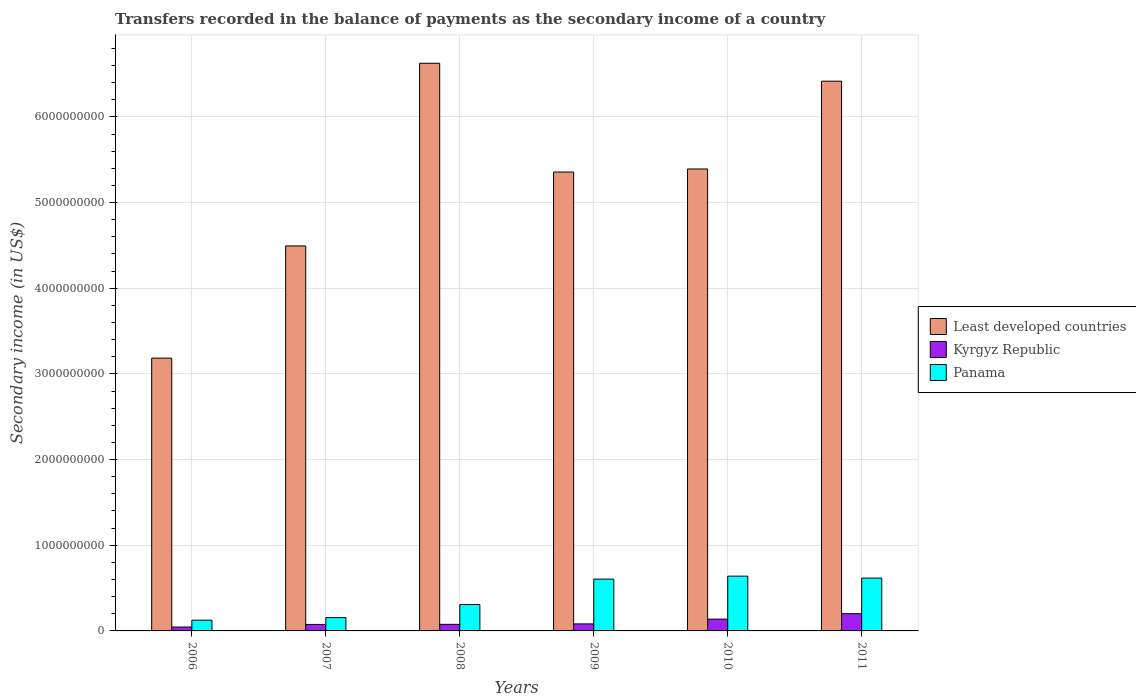How many groups of bars are there?
Offer a terse response. 6. Are the number of bars per tick equal to the number of legend labels?
Make the answer very short. Yes. How many bars are there on the 2nd tick from the right?
Your answer should be very brief. 3. What is the secondary income of in Panama in 2009?
Your answer should be compact. 6.05e+08. Across all years, what is the maximum secondary income of in Kyrgyz Republic?
Your answer should be compact. 2.01e+08. Across all years, what is the minimum secondary income of in Panama?
Your response must be concise. 1.26e+08. What is the total secondary income of in Kyrgyz Republic in the graph?
Give a very brief answer. 6.18e+08. What is the difference between the secondary income of in Panama in 2008 and that in 2010?
Provide a succinct answer. -3.31e+08. What is the difference between the secondary income of in Least developed countries in 2011 and the secondary income of in Panama in 2007?
Provide a short and direct response. 6.26e+09. What is the average secondary income of in Least developed countries per year?
Offer a terse response. 5.24e+09. In the year 2006, what is the difference between the secondary income of in Kyrgyz Republic and secondary income of in Panama?
Your answer should be compact. -8.02e+07. In how many years, is the secondary income of in Least developed countries greater than 4400000000 US$?
Give a very brief answer. 5. What is the ratio of the secondary income of in Kyrgyz Republic in 2009 to that in 2011?
Your answer should be compact. 0.41. What is the difference between the highest and the second highest secondary income of in Panama?
Make the answer very short. 2.26e+07. What is the difference between the highest and the lowest secondary income of in Panama?
Your answer should be compact. 5.14e+08. In how many years, is the secondary income of in Kyrgyz Republic greater than the average secondary income of in Kyrgyz Republic taken over all years?
Your answer should be very brief. 2. Is the sum of the secondary income of in Kyrgyz Republic in 2007 and 2011 greater than the maximum secondary income of in Panama across all years?
Offer a terse response. No. What does the 3rd bar from the left in 2006 represents?
Your answer should be very brief. Panama. What does the 2nd bar from the right in 2007 represents?
Keep it short and to the point. Kyrgyz Republic. Is it the case that in every year, the sum of the secondary income of in Least developed countries and secondary income of in Kyrgyz Republic is greater than the secondary income of in Panama?
Ensure brevity in your answer.  Yes. How many years are there in the graph?
Keep it short and to the point. 6. Are the values on the major ticks of Y-axis written in scientific E-notation?
Offer a terse response. No. Does the graph contain any zero values?
Your answer should be compact. No. How many legend labels are there?
Make the answer very short. 3. What is the title of the graph?
Provide a succinct answer. Transfers recorded in the balance of payments as the secondary income of a country. What is the label or title of the Y-axis?
Your answer should be very brief. Secondary income (in US$). What is the Secondary income (in US$) in Least developed countries in 2006?
Give a very brief answer. 3.18e+09. What is the Secondary income (in US$) in Kyrgyz Republic in 2006?
Ensure brevity in your answer.  4.53e+07. What is the Secondary income (in US$) of Panama in 2006?
Make the answer very short. 1.26e+08. What is the Secondary income (in US$) in Least developed countries in 2007?
Your answer should be compact. 4.49e+09. What is the Secondary income (in US$) of Kyrgyz Republic in 2007?
Offer a terse response. 7.56e+07. What is the Secondary income (in US$) in Panama in 2007?
Provide a short and direct response. 1.56e+08. What is the Secondary income (in US$) in Least developed countries in 2008?
Your answer should be very brief. 6.63e+09. What is the Secondary income (in US$) of Kyrgyz Republic in 2008?
Offer a very short reply. 7.67e+07. What is the Secondary income (in US$) of Panama in 2008?
Keep it short and to the point. 3.08e+08. What is the Secondary income (in US$) of Least developed countries in 2009?
Your response must be concise. 5.36e+09. What is the Secondary income (in US$) of Kyrgyz Republic in 2009?
Provide a succinct answer. 8.20e+07. What is the Secondary income (in US$) in Panama in 2009?
Keep it short and to the point. 6.05e+08. What is the Secondary income (in US$) in Least developed countries in 2010?
Make the answer very short. 5.39e+09. What is the Secondary income (in US$) in Kyrgyz Republic in 2010?
Your answer should be very brief. 1.38e+08. What is the Secondary income (in US$) of Panama in 2010?
Keep it short and to the point. 6.39e+08. What is the Secondary income (in US$) in Least developed countries in 2011?
Ensure brevity in your answer.  6.42e+09. What is the Secondary income (in US$) of Kyrgyz Republic in 2011?
Provide a short and direct response. 2.01e+08. What is the Secondary income (in US$) of Panama in 2011?
Your answer should be very brief. 6.17e+08. Across all years, what is the maximum Secondary income (in US$) in Least developed countries?
Your answer should be very brief. 6.63e+09. Across all years, what is the maximum Secondary income (in US$) in Kyrgyz Republic?
Give a very brief answer. 2.01e+08. Across all years, what is the maximum Secondary income (in US$) of Panama?
Provide a short and direct response. 6.39e+08. Across all years, what is the minimum Secondary income (in US$) of Least developed countries?
Offer a terse response. 3.18e+09. Across all years, what is the minimum Secondary income (in US$) of Kyrgyz Republic?
Provide a succinct answer. 4.53e+07. Across all years, what is the minimum Secondary income (in US$) in Panama?
Ensure brevity in your answer.  1.26e+08. What is the total Secondary income (in US$) of Least developed countries in the graph?
Ensure brevity in your answer.  3.15e+1. What is the total Secondary income (in US$) of Kyrgyz Republic in the graph?
Provide a succinct answer. 6.18e+08. What is the total Secondary income (in US$) of Panama in the graph?
Make the answer very short. 2.45e+09. What is the difference between the Secondary income (in US$) in Least developed countries in 2006 and that in 2007?
Your answer should be very brief. -1.31e+09. What is the difference between the Secondary income (in US$) of Kyrgyz Republic in 2006 and that in 2007?
Your answer should be compact. -3.03e+07. What is the difference between the Secondary income (in US$) in Panama in 2006 and that in 2007?
Keep it short and to the point. -3.05e+07. What is the difference between the Secondary income (in US$) in Least developed countries in 2006 and that in 2008?
Offer a terse response. -3.44e+09. What is the difference between the Secondary income (in US$) in Kyrgyz Republic in 2006 and that in 2008?
Provide a succinct answer. -3.14e+07. What is the difference between the Secondary income (in US$) of Panama in 2006 and that in 2008?
Offer a terse response. -1.82e+08. What is the difference between the Secondary income (in US$) in Least developed countries in 2006 and that in 2009?
Offer a terse response. -2.17e+09. What is the difference between the Secondary income (in US$) of Kyrgyz Republic in 2006 and that in 2009?
Offer a terse response. -3.68e+07. What is the difference between the Secondary income (in US$) of Panama in 2006 and that in 2009?
Your response must be concise. -4.79e+08. What is the difference between the Secondary income (in US$) in Least developed countries in 2006 and that in 2010?
Offer a very short reply. -2.21e+09. What is the difference between the Secondary income (in US$) in Kyrgyz Republic in 2006 and that in 2010?
Provide a short and direct response. -9.25e+07. What is the difference between the Secondary income (in US$) in Panama in 2006 and that in 2010?
Provide a succinct answer. -5.14e+08. What is the difference between the Secondary income (in US$) of Least developed countries in 2006 and that in 2011?
Your response must be concise. -3.23e+09. What is the difference between the Secondary income (in US$) of Kyrgyz Republic in 2006 and that in 2011?
Make the answer very short. -1.56e+08. What is the difference between the Secondary income (in US$) in Panama in 2006 and that in 2011?
Ensure brevity in your answer.  -4.91e+08. What is the difference between the Secondary income (in US$) of Least developed countries in 2007 and that in 2008?
Keep it short and to the point. -2.13e+09. What is the difference between the Secondary income (in US$) of Kyrgyz Republic in 2007 and that in 2008?
Ensure brevity in your answer.  -1.10e+06. What is the difference between the Secondary income (in US$) of Panama in 2007 and that in 2008?
Give a very brief answer. -1.52e+08. What is the difference between the Secondary income (in US$) in Least developed countries in 2007 and that in 2009?
Keep it short and to the point. -8.62e+08. What is the difference between the Secondary income (in US$) in Kyrgyz Republic in 2007 and that in 2009?
Provide a succinct answer. -6.46e+06. What is the difference between the Secondary income (in US$) of Panama in 2007 and that in 2009?
Provide a short and direct response. -4.49e+08. What is the difference between the Secondary income (in US$) of Least developed countries in 2007 and that in 2010?
Your answer should be compact. -8.98e+08. What is the difference between the Secondary income (in US$) in Kyrgyz Republic in 2007 and that in 2010?
Offer a terse response. -6.22e+07. What is the difference between the Secondary income (in US$) of Panama in 2007 and that in 2010?
Provide a succinct answer. -4.83e+08. What is the difference between the Secondary income (in US$) in Least developed countries in 2007 and that in 2011?
Your answer should be very brief. -1.92e+09. What is the difference between the Secondary income (in US$) in Kyrgyz Republic in 2007 and that in 2011?
Offer a very short reply. -1.26e+08. What is the difference between the Secondary income (in US$) in Panama in 2007 and that in 2011?
Keep it short and to the point. -4.61e+08. What is the difference between the Secondary income (in US$) of Least developed countries in 2008 and that in 2009?
Offer a terse response. 1.27e+09. What is the difference between the Secondary income (in US$) of Kyrgyz Republic in 2008 and that in 2009?
Offer a terse response. -5.35e+06. What is the difference between the Secondary income (in US$) of Panama in 2008 and that in 2009?
Provide a short and direct response. -2.97e+08. What is the difference between the Secondary income (in US$) of Least developed countries in 2008 and that in 2010?
Provide a succinct answer. 1.23e+09. What is the difference between the Secondary income (in US$) in Kyrgyz Republic in 2008 and that in 2010?
Offer a terse response. -6.11e+07. What is the difference between the Secondary income (in US$) of Panama in 2008 and that in 2010?
Provide a succinct answer. -3.31e+08. What is the difference between the Secondary income (in US$) of Least developed countries in 2008 and that in 2011?
Your response must be concise. 2.09e+08. What is the difference between the Secondary income (in US$) in Kyrgyz Republic in 2008 and that in 2011?
Provide a succinct answer. -1.24e+08. What is the difference between the Secondary income (in US$) in Panama in 2008 and that in 2011?
Provide a succinct answer. -3.09e+08. What is the difference between the Secondary income (in US$) in Least developed countries in 2009 and that in 2010?
Ensure brevity in your answer.  -3.60e+07. What is the difference between the Secondary income (in US$) of Kyrgyz Republic in 2009 and that in 2010?
Your answer should be compact. -5.58e+07. What is the difference between the Secondary income (in US$) in Panama in 2009 and that in 2010?
Keep it short and to the point. -3.46e+07. What is the difference between the Secondary income (in US$) in Least developed countries in 2009 and that in 2011?
Keep it short and to the point. -1.06e+09. What is the difference between the Secondary income (in US$) of Kyrgyz Republic in 2009 and that in 2011?
Your answer should be compact. -1.19e+08. What is the difference between the Secondary income (in US$) in Panama in 2009 and that in 2011?
Keep it short and to the point. -1.20e+07. What is the difference between the Secondary income (in US$) in Least developed countries in 2010 and that in 2011?
Make the answer very short. -1.02e+09. What is the difference between the Secondary income (in US$) of Kyrgyz Republic in 2010 and that in 2011?
Your answer should be compact. -6.33e+07. What is the difference between the Secondary income (in US$) of Panama in 2010 and that in 2011?
Offer a terse response. 2.26e+07. What is the difference between the Secondary income (in US$) in Least developed countries in 2006 and the Secondary income (in US$) in Kyrgyz Republic in 2007?
Your answer should be very brief. 3.11e+09. What is the difference between the Secondary income (in US$) in Least developed countries in 2006 and the Secondary income (in US$) in Panama in 2007?
Provide a short and direct response. 3.03e+09. What is the difference between the Secondary income (in US$) in Kyrgyz Republic in 2006 and the Secondary income (in US$) in Panama in 2007?
Give a very brief answer. -1.11e+08. What is the difference between the Secondary income (in US$) in Least developed countries in 2006 and the Secondary income (in US$) in Kyrgyz Republic in 2008?
Provide a short and direct response. 3.11e+09. What is the difference between the Secondary income (in US$) of Least developed countries in 2006 and the Secondary income (in US$) of Panama in 2008?
Give a very brief answer. 2.88e+09. What is the difference between the Secondary income (in US$) of Kyrgyz Republic in 2006 and the Secondary income (in US$) of Panama in 2008?
Offer a terse response. -2.63e+08. What is the difference between the Secondary income (in US$) of Least developed countries in 2006 and the Secondary income (in US$) of Kyrgyz Republic in 2009?
Make the answer very short. 3.10e+09. What is the difference between the Secondary income (in US$) in Least developed countries in 2006 and the Secondary income (in US$) in Panama in 2009?
Ensure brevity in your answer.  2.58e+09. What is the difference between the Secondary income (in US$) of Kyrgyz Republic in 2006 and the Secondary income (in US$) of Panama in 2009?
Make the answer very short. -5.59e+08. What is the difference between the Secondary income (in US$) of Least developed countries in 2006 and the Secondary income (in US$) of Kyrgyz Republic in 2010?
Your answer should be compact. 3.05e+09. What is the difference between the Secondary income (in US$) of Least developed countries in 2006 and the Secondary income (in US$) of Panama in 2010?
Your response must be concise. 2.55e+09. What is the difference between the Secondary income (in US$) in Kyrgyz Republic in 2006 and the Secondary income (in US$) in Panama in 2010?
Your response must be concise. -5.94e+08. What is the difference between the Secondary income (in US$) of Least developed countries in 2006 and the Secondary income (in US$) of Kyrgyz Republic in 2011?
Your response must be concise. 2.98e+09. What is the difference between the Secondary income (in US$) in Least developed countries in 2006 and the Secondary income (in US$) in Panama in 2011?
Your answer should be compact. 2.57e+09. What is the difference between the Secondary income (in US$) in Kyrgyz Republic in 2006 and the Secondary income (in US$) in Panama in 2011?
Give a very brief answer. -5.71e+08. What is the difference between the Secondary income (in US$) in Least developed countries in 2007 and the Secondary income (in US$) in Kyrgyz Republic in 2008?
Keep it short and to the point. 4.42e+09. What is the difference between the Secondary income (in US$) in Least developed countries in 2007 and the Secondary income (in US$) in Panama in 2008?
Keep it short and to the point. 4.19e+09. What is the difference between the Secondary income (in US$) of Kyrgyz Republic in 2007 and the Secondary income (in US$) of Panama in 2008?
Your answer should be very brief. -2.32e+08. What is the difference between the Secondary income (in US$) in Least developed countries in 2007 and the Secondary income (in US$) in Kyrgyz Republic in 2009?
Provide a short and direct response. 4.41e+09. What is the difference between the Secondary income (in US$) in Least developed countries in 2007 and the Secondary income (in US$) in Panama in 2009?
Your response must be concise. 3.89e+09. What is the difference between the Secondary income (in US$) of Kyrgyz Republic in 2007 and the Secondary income (in US$) of Panama in 2009?
Give a very brief answer. -5.29e+08. What is the difference between the Secondary income (in US$) of Least developed countries in 2007 and the Secondary income (in US$) of Kyrgyz Republic in 2010?
Your answer should be compact. 4.36e+09. What is the difference between the Secondary income (in US$) in Least developed countries in 2007 and the Secondary income (in US$) in Panama in 2010?
Your response must be concise. 3.85e+09. What is the difference between the Secondary income (in US$) in Kyrgyz Republic in 2007 and the Secondary income (in US$) in Panama in 2010?
Your answer should be very brief. -5.64e+08. What is the difference between the Secondary income (in US$) of Least developed countries in 2007 and the Secondary income (in US$) of Kyrgyz Republic in 2011?
Give a very brief answer. 4.29e+09. What is the difference between the Secondary income (in US$) of Least developed countries in 2007 and the Secondary income (in US$) of Panama in 2011?
Ensure brevity in your answer.  3.88e+09. What is the difference between the Secondary income (in US$) in Kyrgyz Republic in 2007 and the Secondary income (in US$) in Panama in 2011?
Your answer should be compact. -5.41e+08. What is the difference between the Secondary income (in US$) in Least developed countries in 2008 and the Secondary income (in US$) in Kyrgyz Republic in 2009?
Your answer should be very brief. 6.54e+09. What is the difference between the Secondary income (in US$) of Least developed countries in 2008 and the Secondary income (in US$) of Panama in 2009?
Your response must be concise. 6.02e+09. What is the difference between the Secondary income (in US$) in Kyrgyz Republic in 2008 and the Secondary income (in US$) in Panama in 2009?
Ensure brevity in your answer.  -5.28e+08. What is the difference between the Secondary income (in US$) of Least developed countries in 2008 and the Secondary income (in US$) of Kyrgyz Republic in 2010?
Your answer should be very brief. 6.49e+09. What is the difference between the Secondary income (in US$) in Least developed countries in 2008 and the Secondary income (in US$) in Panama in 2010?
Your response must be concise. 5.99e+09. What is the difference between the Secondary income (in US$) of Kyrgyz Republic in 2008 and the Secondary income (in US$) of Panama in 2010?
Keep it short and to the point. -5.63e+08. What is the difference between the Secondary income (in US$) in Least developed countries in 2008 and the Secondary income (in US$) in Kyrgyz Republic in 2011?
Offer a terse response. 6.42e+09. What is the difference between the Secondary income (in US$) of Least developed countries in 2008 and the Secondary income (in US$) of Panama in 2011?
Keep it short and to the point. 6.01e+09. What is the difference between the Secondary income (in US$) in Kyrgyz Republic in 2008 and the Secondary income (in US$) in Panama in 2011?
Your answer should be very brief. -5.40e+08. What is the difference between the Secondary income (in US$) in Least developed countries in 2009 and the Secondary income (in US$) in Kyrgyz Republic in 2010?
Make the answer very short. 5.22e+09. What is the difference between the Secondary income (in US$) of Least developed countries in 2009 and the Secondary income (in US$) of Panama in 2010?
Provide a short and direct response. 4.72e+09. What is the difference between the Secondary income (in US$) of Kyrgyz Republic in 2009 and the Secondary income (in US$) of Panama in 2010?
Keep it short and to the point. -5.57e+08. What is the difference between the Secondary income (in US$) of Least developed countries in 2009 and the Secondary income (in US$) of Kyrgyz Republic in 2011?
Offer a terse response. 5.16e+09. What is the difference between the Secondary income (in US$) in Least developed countries in 2009 and the Secondary income (in US$) in Panama in 2011?
Ensure brevity in your answer.  4.74e+09. What is the difference between the Secondary income (in US$) of Kyrgyz Republic in 2009 and the Secondary income (in US$) of Panama in 2011?
Keep it short and to the point. -5.35e+08. What is the difference between the Secondary income (in US$) of Least developed countries in 2010 and the Secondary income (in US$) of Kyrgyz Republic in 2011?
Provide a succinct answer. 5.19e+09. What is the difference between the Secondary income (in US$) of Least developed countries in 2010 and the Secondary income (in US$) of Panama in 2011?
Offer a terse response. 4.78e+09. What is the difference between the Secondary income (in US$) in Kyrgyz Republic in 2010 and the Secondary income (in US$) in Panama in 2011?
Keep it short and to the point. -4.79e+08. What is the average Secondary income (in US$) of Least developed countries per year?
Provide a short and direct response. 5.24e+09. What is the average Secondary income (in US$) in Kyrgyz Republic per year?
Give a very brief answer. 1.03e+08. What is the average Secondary income (in US$) in Panama per year?
Provide a succinct answer. 4.08e+08. In the year 2006, what is the difference between the Secondary income (in US$) of Least developed countries and Secondary income (in US$) of Kyrgyz Republic?
Your answer should be very brief. 3.14e+09. In the year 2006, what is the difference between the Secondary income (in US$) in Least developed countries and Secondary income (in US$) in Panama?
Provide a succinct answer. 3.06e+09. In the year 2006, what is the difference between the Secondary income (in US$) in Kyrgyz Republic and Secondary income (in US$) in Panama?
Make the answer very short. -8.02e+07. In the year 2007, what is the difference between the Secondary income (in US$) of Least developed countries and Secondary income (in US$) of Kyrgyz Republic?
Your answer should be very brief. 4.42e+09. In the year 2007, what is the difference between the Secondary income (in US$) in Least developed countries and Secondary income (in US$) in Panama?
Provide a short and direct response. 4.34e+09. In the year 2007, what is the difference between the Secondary income (in US$) in Kyrgyz Republic and Secondary income (in US$) in Panama?
Ensure brevity in your answer.  -8.04e+07. In the year 2008, what is the difference between the Secondary income (in US$) of Least developed countries and Secondary income (in US$) of Kyrgyz Republic?
Provide a succinct answer. 6.55e+09. In the year 2008, what is the difference between the Secondary income (in US$) of Least developed countries and Secondary income (in US$) of Panama?
Provide a short and direct response. 6.32e+09. In the year 2008, what is the difference between the Secondary income (in US$) of Kyrgyz Republic and Secondary income (in US$) of Panama?
Provide a succinct answer. -2.31e+08. In the year 2009, what is the difference between the Secondary income (in US$) in Least developed countries and Secondary income (in US$) in Kyrgyz Republic?
Keep it short and to the point. 5.27e+09. In the year 2009, what is the difference between the Secondary income (in US$) of Least developed countries and Secondary income (in US$) of Panama?
Make the answer very short. 4.75e+09. In the year 2009, what is the difference between the Secondary income (in US$) in Kyrgyz Republic and Secondary income (in US$) in Panama?
Ensure brevity in your answer.  -5.23e+08. In the year 2010, what is the difference between the Secondary income (in US$) in Least developed countries and Secondary income (in US$) in Kyrgyz Republic?
Provide a short and direct response. 5.25e+09. In the year 2010, what is the difference between the Secondary income (in US$) of Least developed countries and Secondary income (in US$) of Panama?
Offer a very short reply. 4.75e+09. In the year 2010, what is the difference between the Secondary income (in US$) of Kyrgyz Republic and Secondary income (in US$) of Panama?
Keep it short and to the point. -5.01e+08. In the year 2011, what is the difference between the Secondary income (in US$) of Least developed countries and Secondary income (in US$) of Kyrgyz Republic?
Make the answer very short. 6.22e+09. In the year 2011, what is the difference between the Secondary income (in US$) in Least developed countries and Secondary income (in US$) in Panama?
Provide a short and direct response. 5.80e+09. In the year 2011, what is the difference between the Secondary income (in US$) in Kyrgyz Republic and Secondary income (in US$) in Panama?
Provide a short and direct response. -4.15e+08. What is the ratio of the Secondary income (in US$) of Least developed countries in 2006 to that in 2007?
Make the answer very short. 0.71. What is the ratio of the Secondary income (in US$) of Kyrgyz Republic in 2006 to that in 2007?
Ensure brevity in your answer.  0.6. What is the ratio of the Secondary income (in US$) of Panama in 2006 to that in 2007?
Provide a succinct answer. 0.8. What is the ratio of the Secondary income (in US$) in Least developed countries in 2006 to that in 2008?
Your response must be concise. 0.48. What is the ratio of the Secondary income (in US$) in Kyrgyz Republic in 2006 to that in 2008?
Make the answer very short. 0.59. What is the ratio of the Secondary income (in US$) in Panama in 2006 to that in 2008?
Offer a very short reply. 0.41. What is the ratio of the Secondary income (in US$) of Least developed countries in 2006 to that in 2009?
Provide a short and direct response. 0.59. What is the ratio of the Secondary income (in US$) in Kyrgyz Republic in 2006 to that in 2009?
Provide a short and direct response. 0.55. What is the ratio of the Secondary income (in US$) of Panama in 2006 to that in 2009?
Your answer should be compact. 0.21. What is the ratio of the Secondary income (in US$) of Least developed countries in 2006 to that in 2010?
Keep it short and to the point. 0.59. What is the ratio of the Secondary income (in US$) in Kyrgyz Republic in 2006 to that in 2010?
Your response must be concise. 0.33. What is the ratio of the Secondary income (in US$) of Panama in 2006 to that in 2010?
Your answer should be very brief. 0.2. What is the ratio of the Secondary income (in US$) of Least developed countries in 2006 to that in 2011?
Provide a succinct answer. 0.5. What is the ratio of the Secondary income (in US$) in Kyrgyz Republic in 2006 to that in 2011?
Ensure brevity in your answer.  0.23. What is the ratio of the Secondary income (in US$) in Panama in 2006 to that in 2011?
Ensure brevity in your answer.  0.2. What is the ratio of the Secondary income (in US$) in Least developed countries in 2007 to that in 2008?
Your answer should be very brief. 0.68. What is the ratio of the Secondary income (in US$) of Kyrgyz Republic in 2007 to that in 2008?
Your answer should be very brief. 0.99. What is the ratio of the Secondary income (in US$) of Panama in 2007 to that in 2008?
Your answer should be compact. 0.51. What is the ratio of the Secondary income (in US$) of Least developed countries in 2007 to that in 2009?
Your answer should be compact. 0.84. What is the ratio of the Secondary income (in US$) of Kyrgyz Republic in 2007 to that in 2009?
Make the answer very short. 0.92. What is the ratio of the Secondary income (in US$) of Panama in 2007 to that in 2009?
Your response must be concise. 0.26. What is the ratio of the Secondary income (in US$) in Least developed countries in 2007 to that in 2010?
Provide a succinct answer. 0.83. What is the ratio of the Secondary income (in US$) in Kyrgyz Republic in 2007 to that in 2010?
Offer a very short reply. 0.55. What is the ratio of the Secondary income (in US$) in Panama in 2007 to that in 2010?
Your response must be concise. 0.24. What is the ratio of the Secondary income (in US$) in Least developed countries in 2007 to that in 2011?
Your answer should be very brief. 0.7. What is the ratio of the Secondary income (in US$) in Kyrgyz Republic in 2007 to that in 2011?
Give a very brief answer. 0.38. What is the ratio of the Secondary income (in US$) in Panama in 2007 to that in 2011?
Offer a terse response. 0.25. What is the ratio of the Secondary income (in US$) in Least developed countries in 2008 to that in 2009?
Ensure brevity in your answer.  1.24. What is the ratio of the Secondary income (in US$) of Kyrgyz Republic in 2008 to that in 2009?
Make the answer very short. 0.93. What is the ratio of the Secondary income (in US$) of Panama in 2008 to that in 2009?
Keep it short and to the point. 0.51. What is the ratio of the Secondary income (in US$) of Least developed countries in 2008 to that in 2010?
Offer a very short reply. 1.23. What is the ratio of the Secondary income (in US$) of Kyrgyz Republic in 2008 to that in 2010?
Ensure brevity in your answer.  0.56. What is the ratio of the Secondary income (in US$) in Panama in 2008 to that in 2010?
Your answer should be very brief. 0.48. What is the ratio of the Secondary income (in US$) in Least developed countries in 2008 to that in 2011?
Give a very brief answer. 1.03. What is the ratio of the Secondary income (in US$) of Kyrgyz Republic in 2008 to that in 2011?
Your response must be concise. 0.38. What is the ratio of the Secondary income (in US$) of Panama in 2008 to that in 2011?
Ensure brevity in your answer.  0.5. What is the ratio of the Secondary income (in US$) in Least developed countries in 2009 to that in 2010?
Offer a very short reply. 0.99. What is the ratio of the Secondary income (in US$) of Kyrgyz Republic in 2009 to that in 2010?
Ensure brevity in your answer.  0.6. What is the ratio of the Secondary income (in US$) of Panama in 2009 to that in 2010?
Offer a terse response. 0.95. What is the ratio of the Secondary income (in US$) in Least developed countries in 2009 to that in 2011?
Your answer should be very brief. 0.83. What is the ratio of the Secondary income (in US$) in Kyrgyz Republic in 2009 to that in 2011?
Your response must be concise. 0.41. What is the ratio of the Secondary income (in US$) in Panama in 2009 to that in 2011?
Your answer should be compact. 0.98. What is the ratio of the Secondary income (in US$) in Least developed countries in 2010 to that in 2011?
Give a very brief answer. 0.84. What is the ratio of the Secondary income (in US$) of Kyrgyz Republic in 2010 to that in 2011?
Your answer should be compact. 0.69. What is the ratio of the Secondary income (in US$) of Panama in 2010 to that in 2011?
Your response must be concise. 1.04. What is the difference between the highest and the second highest Secondary income (in US$) in Least developed countries?
Offer a terse response. 2.09e+08. What is the difference between the highest and the second highest Secondary income (in US$) in Kyrgyz Republic?
Provide a short and direct response. 6.33e+07. What is the difference between the highest and the second highest Secondary income (in US$) of Panama?
Provide a short and direct response. 2.26e+07. What is the difference between the highest and the lowest Secondary income (in US$) in Least developed countries?
Your answer should be very brief. 3.44e+09. What is the difference between the highest and the lowest Secondary income (in US$) of Kyrgyz Republic?
Your answer should be compact. 1.56e+08. What is the difference between the highest and the lowest Secondary income (in US$) in Panama?
Your answer should be compact. 5.14e+08. 